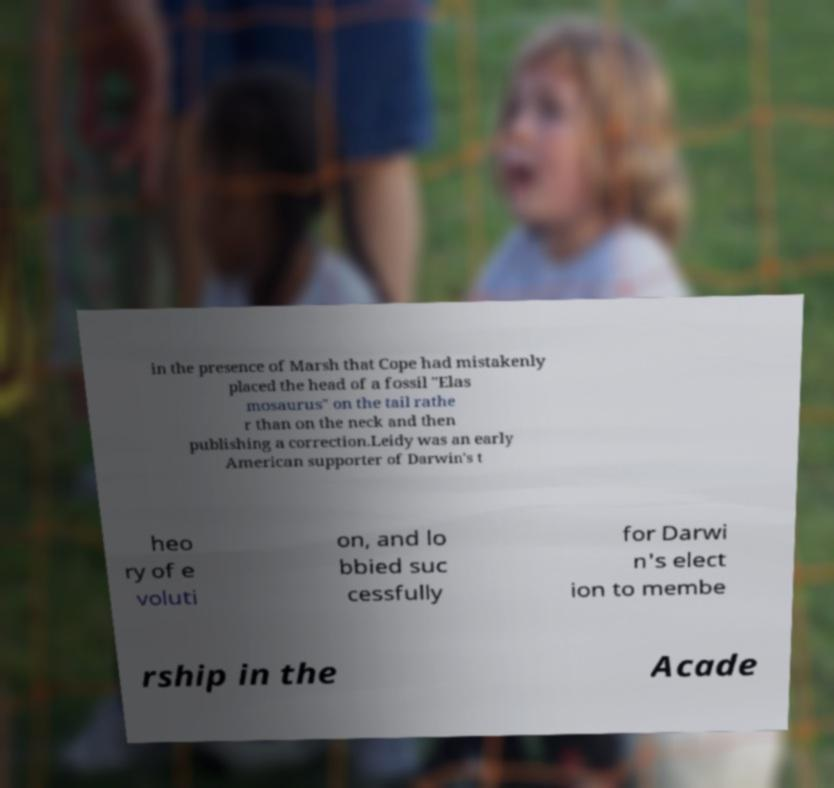I need the written content from this picture converted into text. Can you do that? in the presence of Marsh that Cope had mistakenly placed the head of a fossil "Elas mosaurus" on the tail rathe r than on the neck and then publishing a correction.Leidy was an early American supporter of Darwin's t heo ry of e voluti on, and lo bbied suc cessfully for Darwi n's elect ion to membe rship in the Acade 